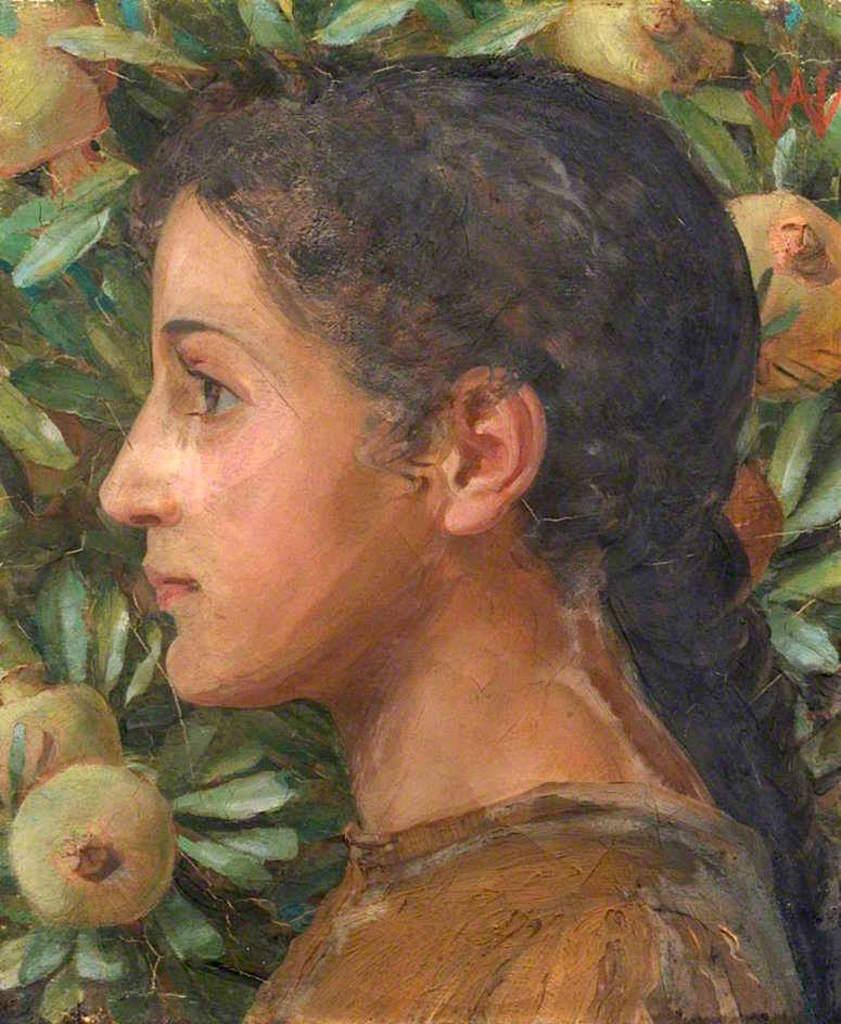What is depicted in the painting that is visible in the image? There is a painting of a woman in the image. What other items can be seen in the image besides the painting? There are fruits and leaves visible in the image. Where is the hall located in the image? There is no hall present in the image. What type of oil is used to create the painting in the image? There is no information about the type of oil used in the painting in the image. 